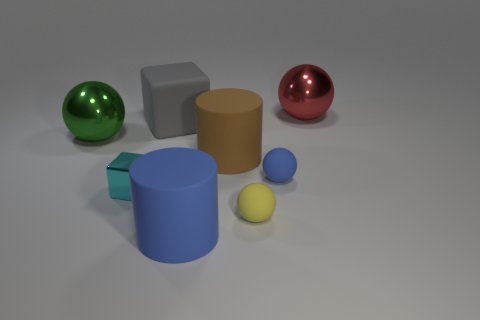How many cylinders are big blue matte objects or green objects?
Provide a short and direct response. 1. What number of other big blue objects have the same shape as the big blue rubber thing?
Make the answer very short. 0. Is the number of matte objects that are in front of the green metallic sphere greater than the number of large spheres that are right of the cyan metallic cube?
Your answer should be compact. Yes. The blue rubber sphere has what size?
Offer a terse response. Small. There is a red object that is the same size as the blue matte cylinder; what is its material?
Offer a very short reply. Metal. What color is the cube in front of the blue matte ball?
Offer a very short reply. Cyan. How many tiny matte cubes are there?
Provide a short and direct response. 0. There is a rubber ball in front of the blue thing behind the small cyan metallic block; is there a large metal thing that is left of it?
Provide a succinct answer. Yes. There is a blue thing that is the same size as the yellow rubber object; what shape is it?
Give a very brief answer. Sphere. What number of other objects are the same color as the tiny block?
Provide a succinct answer. 0. 